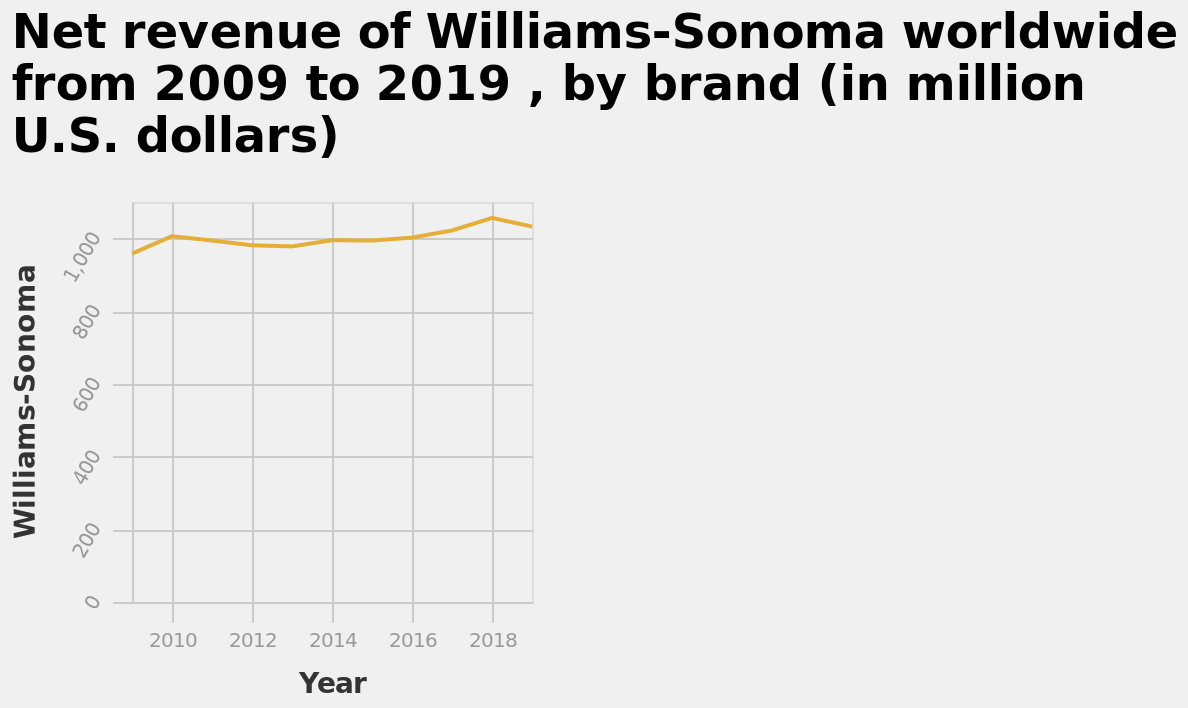<image>
 When was the highest net revenue for Williams and Sonoma?  The highest net revenue for Williams and Sonoma was in 2018. How many brands are represented in the line plot? The line plot represents the net revenue of Williams-Sonoma worldwide, but it does not specify the number of brands. 